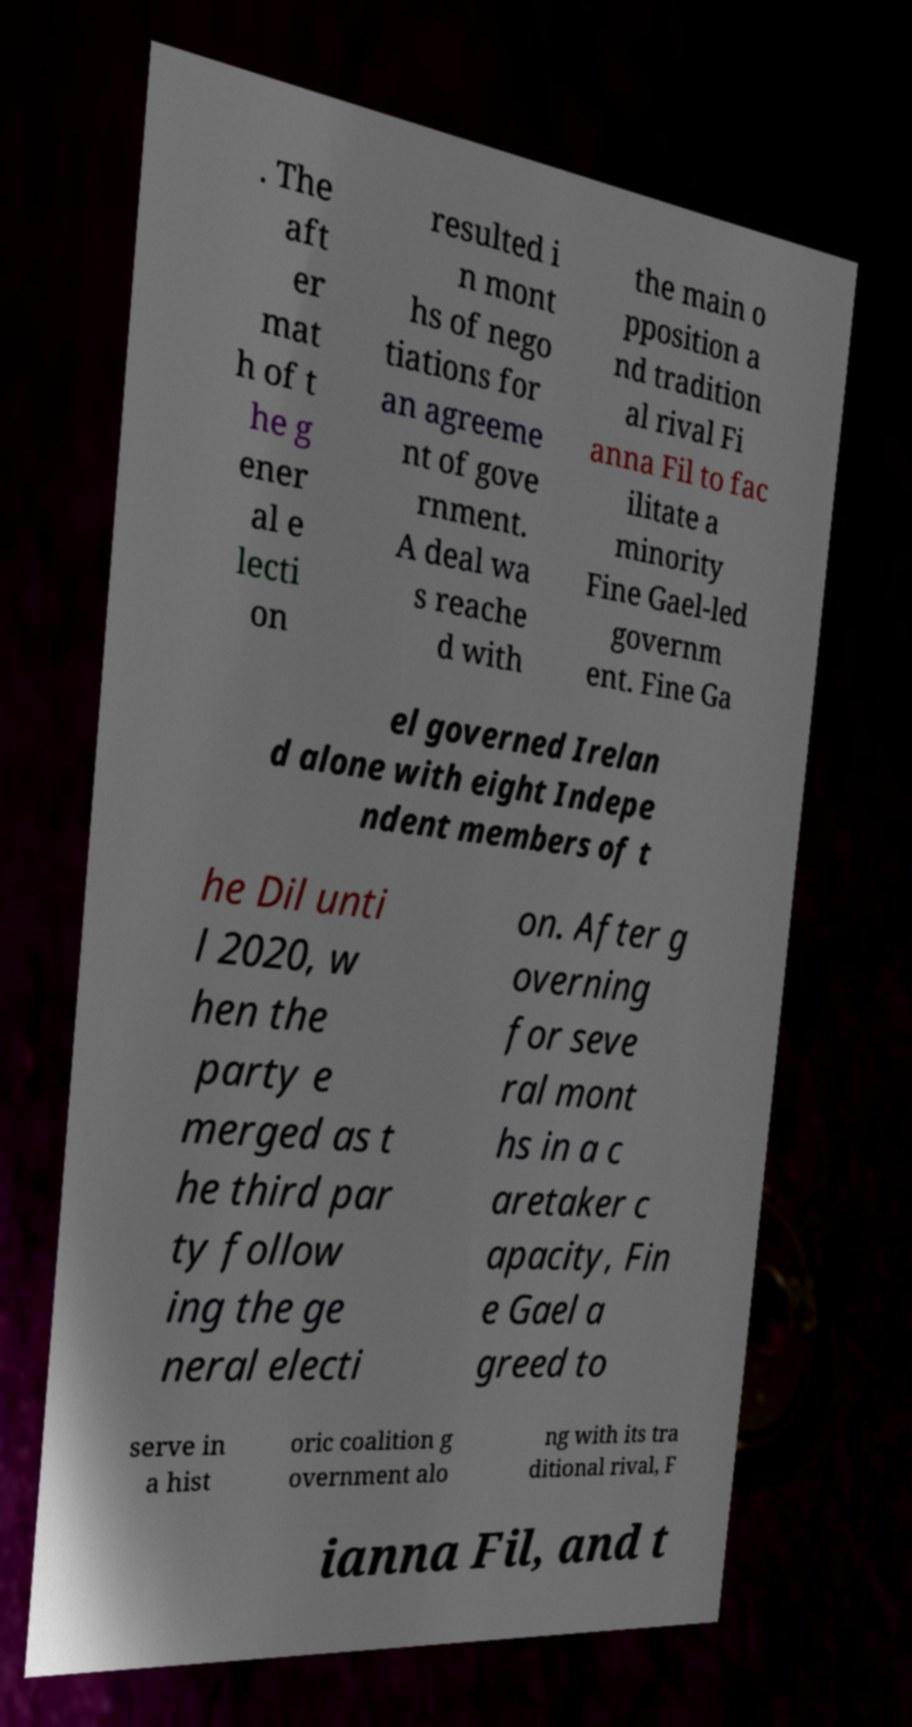Could you assist in decoding the text presented in this image and type it out clearly? . The aft er mat h of t he g ener al e lecti on resulted i n mont hs of nego tiations for an agreeme nt of gove rnment. A deal wa s reache d with the main o pposition a nd tradition al rival Fi anna Fil to fac ilitate a minority Fine Gael-led governm ent. Fine Ga el governed Irelan d alone with eight Indepe ndent members of t he Dil unti l 2020, w hen the party e merged as t he third par ty follow ing the ge neral electi on. After g overning for seve ral mont hs in a c aretaker c apacity, Fin e Gael a greed to serve in a hist oric coalition g overnment alo ng with its tra ditional rival, F ianna Fil, and t 